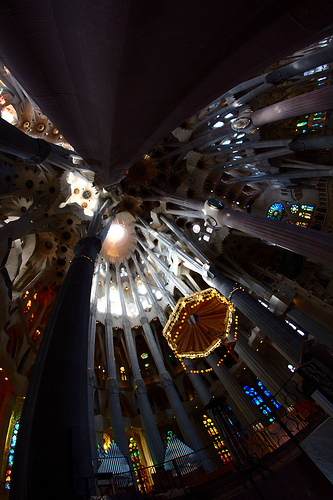<image>
Is the lamp next to the hall? No. The lamp is not positioned next to the hall. They are located in different areas of the scene. 